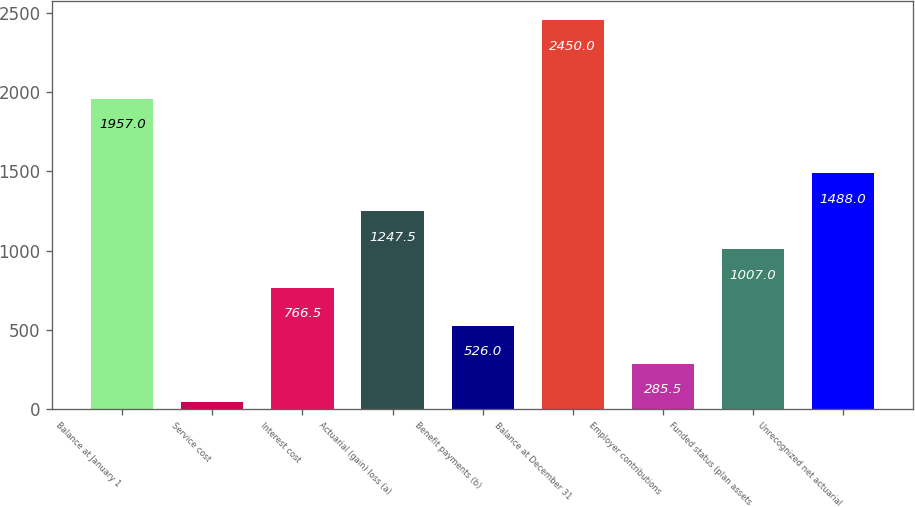Convert chart. <chart><loc_0><loc_0><loc_500><loc_500><bar_chart><fcel>Balance at January 1<fcel>Service cost<fcel>Interest cost<fcel>Actuarial (gain) loss (a)<fcel>Benefit payments (b)<fcel>Balance at December 31<fcel>Employer contributions<fcel>Funded status (plan assets<fcel>Unrecognized net actuarial<nl><fcel>1957<fcel>45<fcel>766.5<fcel>1247.5<fcel>526<fcel>2450<fcel>285.5<fcel>1007<fcel>1488<nl></chart> 